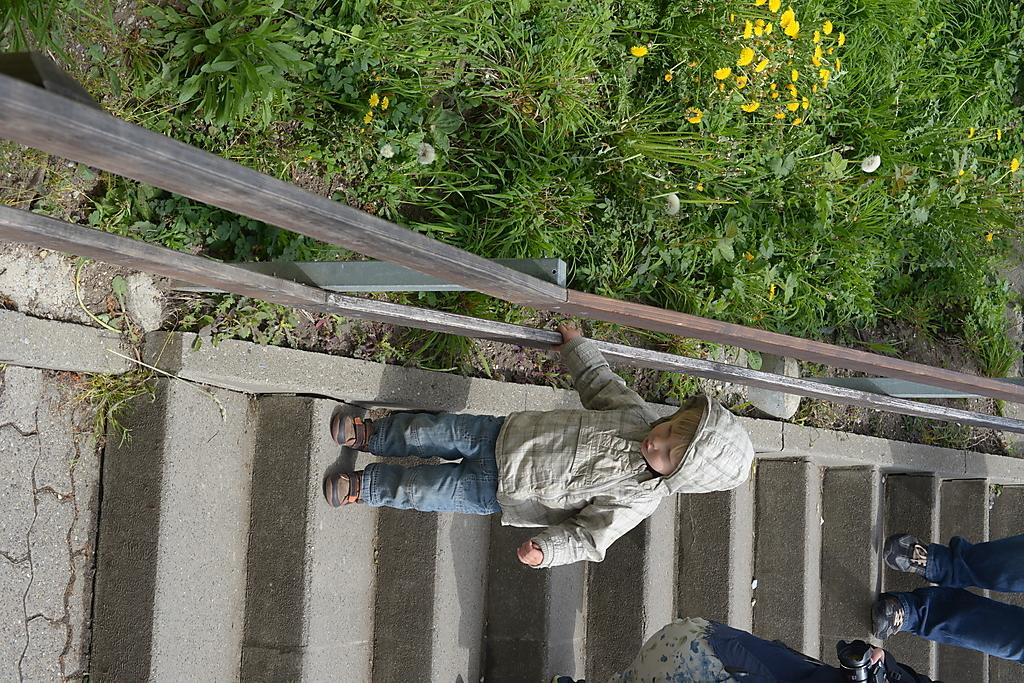How many people are in the image? There are two persons in the image. Who else is present in the image besides the two persons? There is a kid in the image. What are the persons and the kid doing in the image? The persons and the kid are walking on steps. What is located beside the steps in the image? There is a fencing beside the steps. What type of vegetation is present beside the fencing? There are plants beside the fencing. What type of picture is hanging on the wall in the image? There is no wall or picture present in the image; it features two persons, a kid, and steps with fencing and plants. 